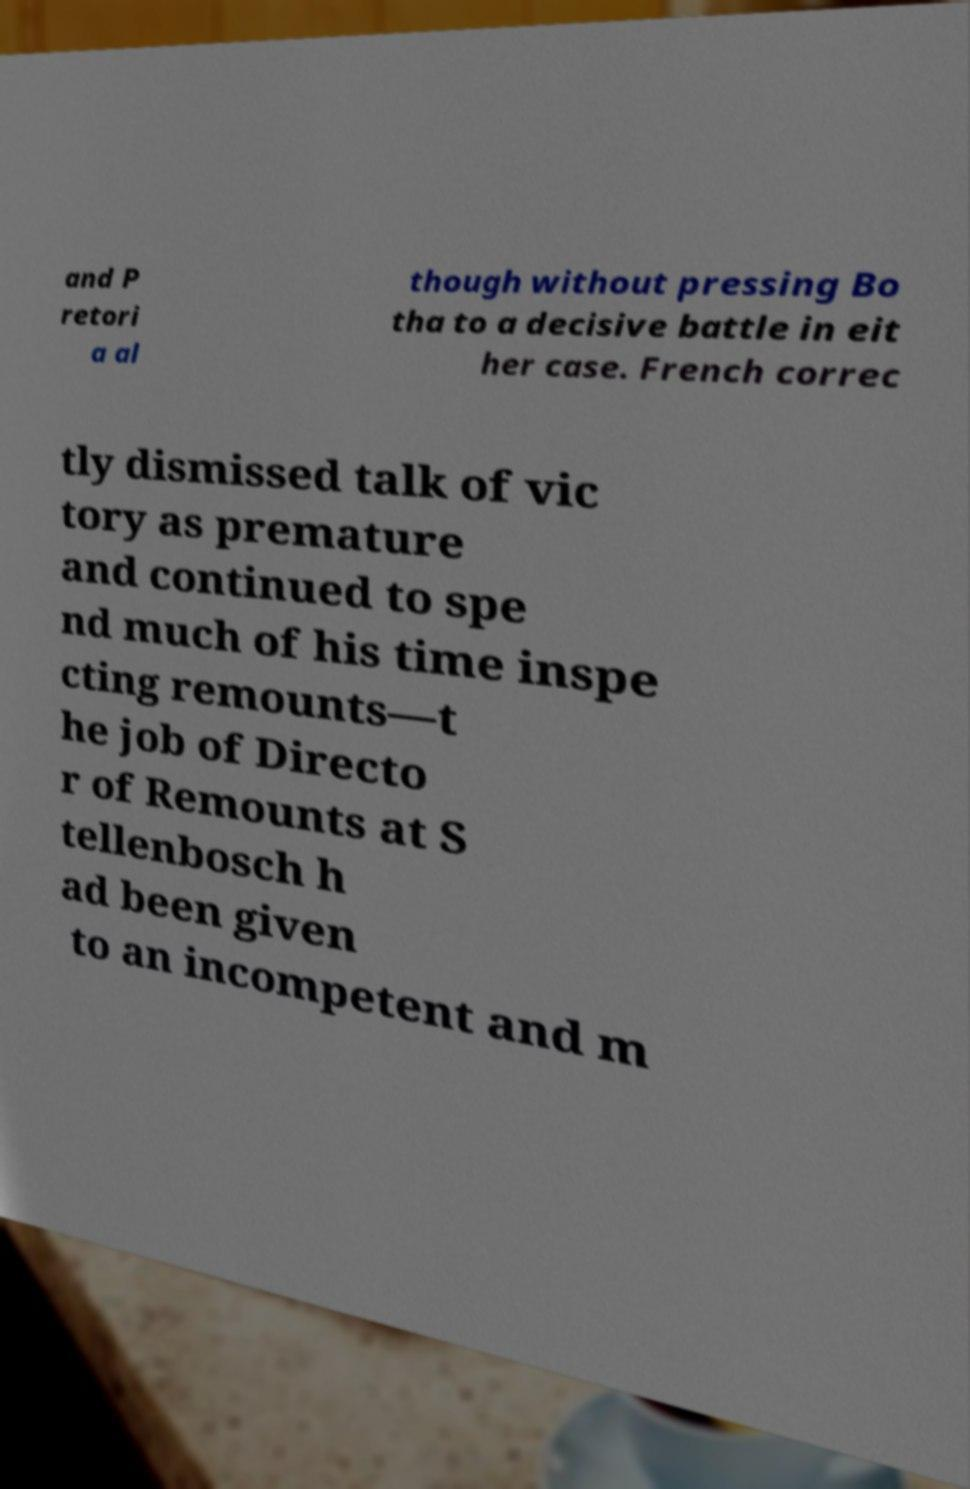Please identify and transcribe the text found in this image. and P retori a al though without pressing Bo tha to a decisive battle in eit her case. French correc tly dismissed talk of vic tory as premature and continued to spe nd much of his time inspe cting remounts—t he job of Directo r of Remounts at S tellenbosch h ad been given to an incompetent and m 